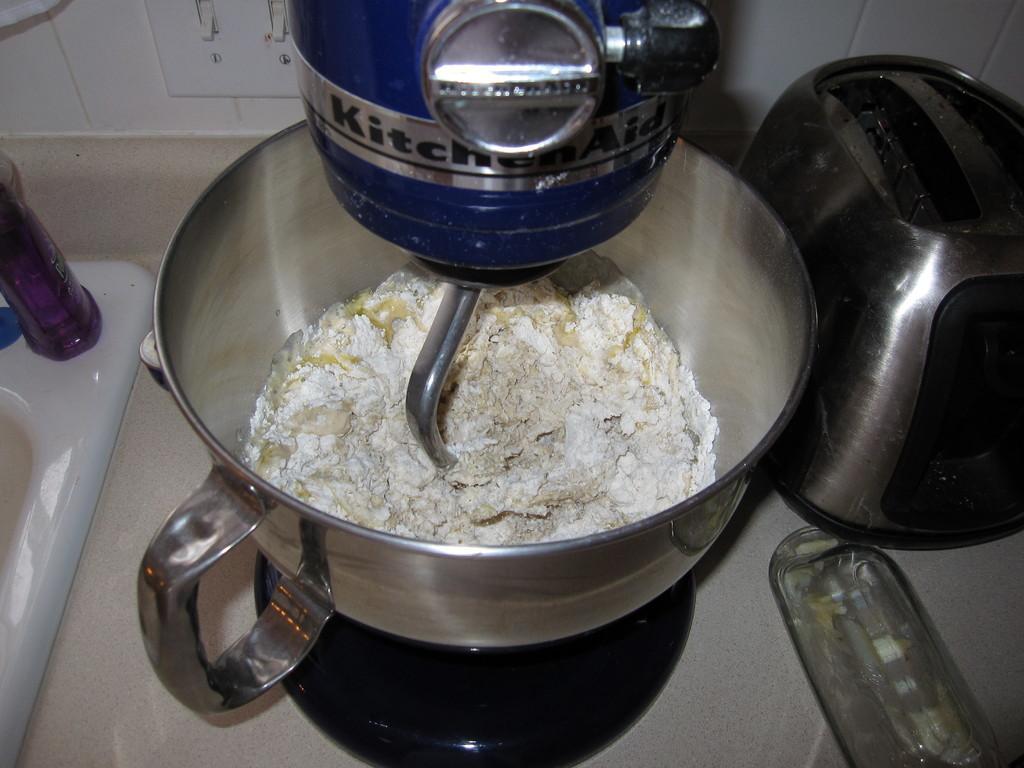Could you give a brief overview of what you see in this image? In this image there is food in a blender, to the right side of the blender there is a toaster, on the left there is a bottle on top of a sink, behind the blender there is electrical switchboard. 